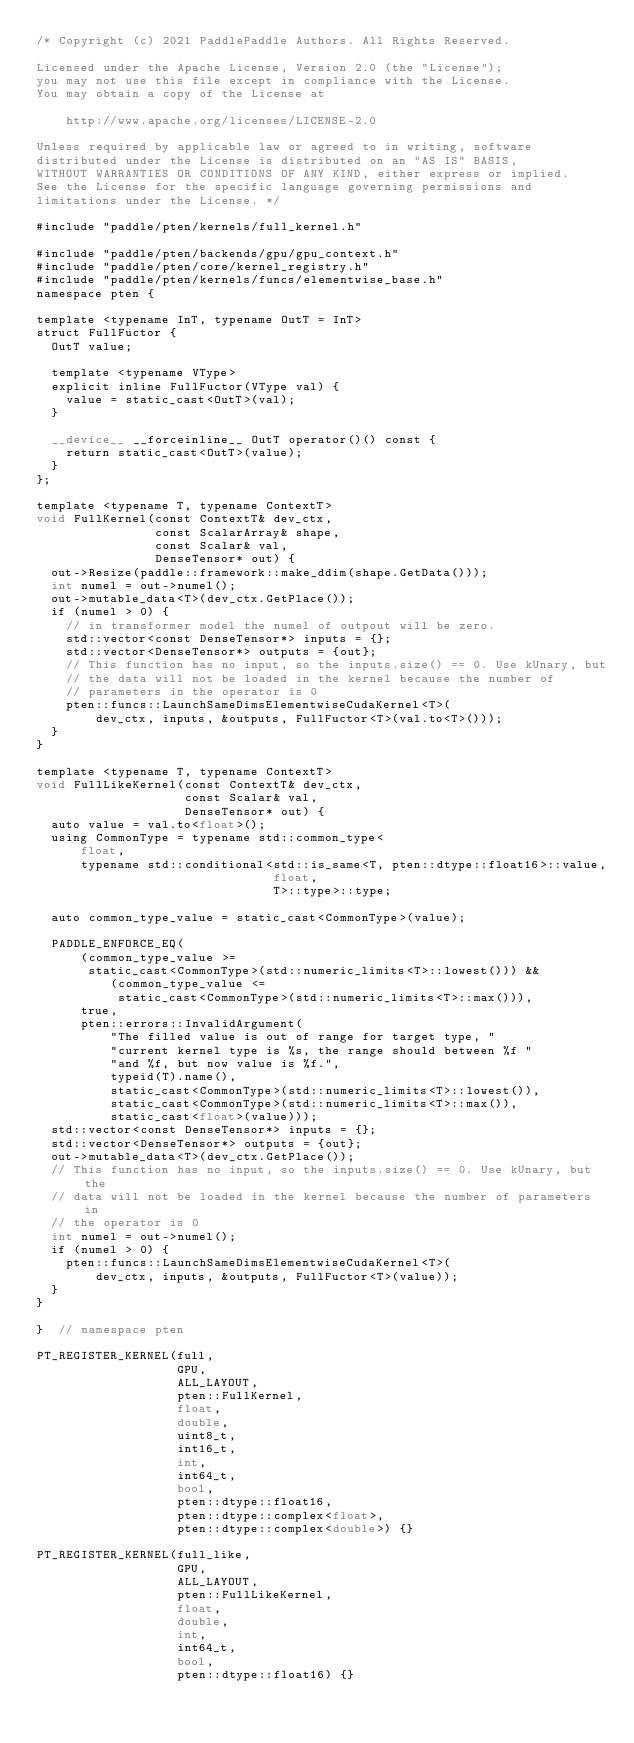Convert code to text. <code><loc_0><loc_0><loc_500><loc_500><_Cuda_>/* Copyright (c) 2021 PaddlePaddle Authors. All Rights Reserved.

Licensed under the Apache License, Version 2.0 (the "License");
you may not use this file except in compliance with the License.
You may obtain a copy of the License at

    http://www.apache.org/licenses/LICENSE-2.0

Unless required by applicable law or agreed to in writing, software
distributed under the License is distributed on an "AS IS" BASIS,
WITHOUT WARRANTIES OR CONDITIONS OF ANY KIND, either express or implied.
See the License for the specific language governing permissions and
limitations under the License. */

#include "paddle/pten/kernels/full_kernel.h"

#include "paddle/pten/backends/gpu/gpu_context.h"
#include "paddle/pten/core/kernel_registry.h"
#include "paddle/pten/kernels/funcs/elementwise_base.h"
namespace pten {

template <typename InT, typename OutT = InT>
struct FullFuctor {
  OutT value;

  template <typename VType>
  explicit inline FullFuctor(VType val) {
    value = static_cast<OutT>(val);
  }

  __device__ __forceinline__ OutT operator()() const {
    return static_cast<OutT>(value);
  }
};

template <typename T, typename ContextT>
void FullKernel(const ContextT& dev_ctx,
                const ScalarArray& shape,
                const Scalar& val,
                DenseTensor* out) {
  out->Resize(paddle::framework::make_ddim(shape.GetData()));
  int numel = out->numel();
  out->mutable_data<T>(dev_ctx.GetPlace());
  if (numel > 0) {
    // in transformer model the numel of outpout will be zero.
    std::vector<const DenseTensor*> inputs = {};
    std::vector<DenseTensor*> outputs = {out};
    // This function has no input, so the inputs.size() == 0. Use kUnary, but
    // the data will not be loaded in the kernel because the number of
    // parameters in the operator is 0
    pten::funcs::LaunchSameDimsElementwiseCudaKernel<T>(
        dev_ctx, inputs, &outputs, FullFuctor<T>(val.to<T>()));
  }
}

template <typename T, typename ContextT>
void FullLikeKernel(const ContextT& dev_ctx,
                    const Scalar& val,
                    DenseTensor* out) {
  auto value = val.to<float>();
  using CommonType = typename std::common_type<
      float,
      typename std::conditional<std::is_same<T, pten::dtype::float16>::value,
                                float,
                                T>::type>::type;

  auto common_type_value = static_cast<CommonType>(value);

  PADDLE_ENFORCE_EQ(
      (common_type_value >=
       static_cast<CommonType>(std::numeric_limits<T>::lowest())) &&
          (common_type_value <=
           static_cast<CommonType>(std::numeric_limits<T>::max())),
      true,
      pten::errors::InvalidArgument(
          "The filled value is out of range for target type, "
          "current kernel type is %s, the range should between %f "
          "and %f, but now value is %f.",
          typeid(T).name(),
          static_cast<CommonType>(std::numeric_limits<T>::lowest()),
          static_cast<CommonType>(std::numeric_limits<T>::max()),
          static_cast<float>(value)));
  std::vector<const DenseTensor*> inputs = {};
  std::vector<DenseTensor*> outputs = {out};
  out->mutable_data<T>(dev_ctx.GetPlace());
  // This function has no input, so the inputs.size() == 0. Use kUnary, but the
  // data will not be loaded in the kernel because the number of parameters in
  // the operator is 0
  int numel = out->numel();
  if (numel > 0) {
    pten::funcs::LaunchSameDimsElementwiseCudaKernel<T>(
        dev_ctx, inputs, &outputs, FullFuctor<T>(value));
  }
}

}  // namespace pten

PT_REGISTER_KERNEL(full,
                   GPU,
                   ALL_LAYOUT,
                   pten::FullKernel,
                   float,
                   double,
                   uint8_t,
                   int16_t,
                   int,
                   int64_t,
                   bool,
                   pten::dtype::float16,
                   pten::dtype::complex<float>,
                   pten::dtype::complex<double>) {}

PT_REGISTER_KERNEL(full_like,
                   GPU,
                   ALL_LAYOUT,
                   pten::FullLikeKernel,
                   float,
                   double,
                   int,
                   int64_t,
                   bool,
                   pten::dtype::float16) {}
</code> 